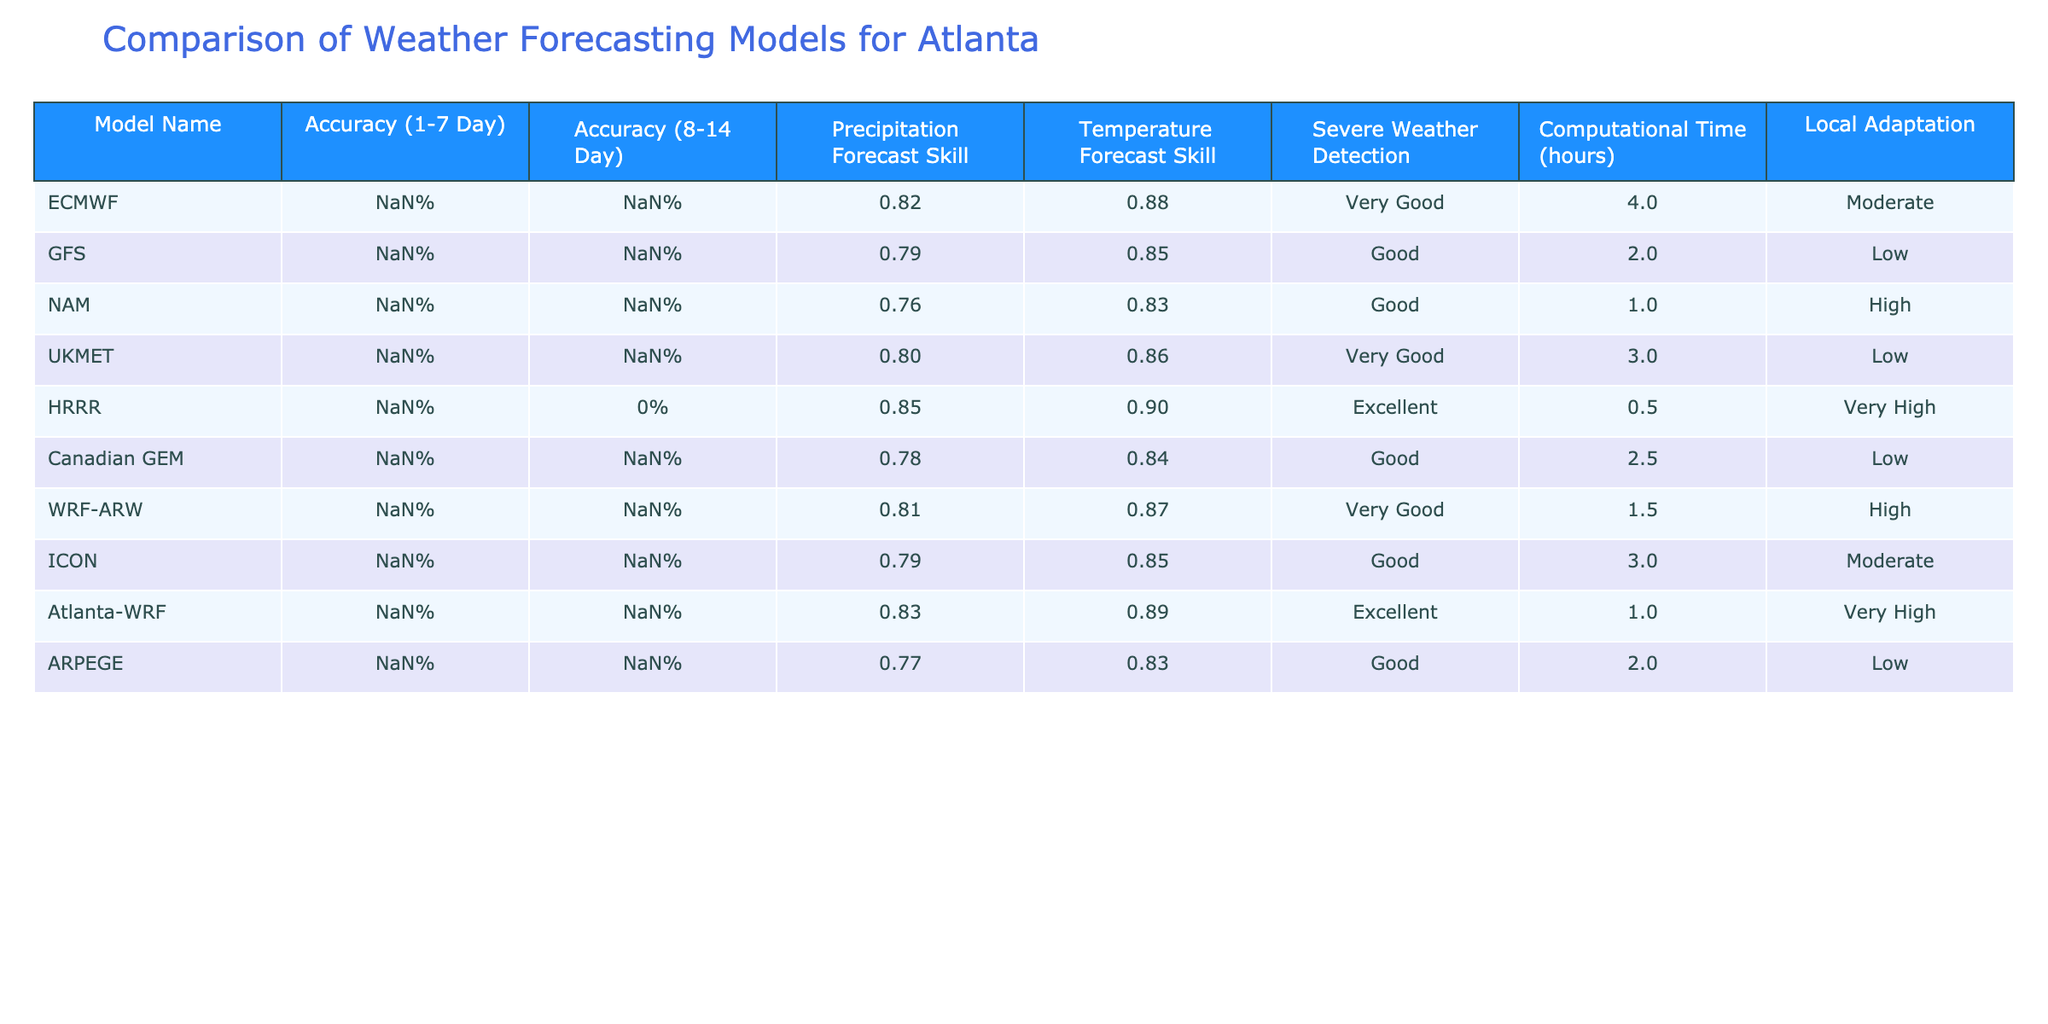What's the highest accuracy for predicting 1-7 day weather? The model with the highest accuracy for predicting 1-7 day weather is HRRR with an accuracy of 88%.
Answer: 88% Which model has the best severe weather detection capability? According to the table, the HRRR and Atlanta-WRF models are rated "Excellent" for severe weather detection, which is the highest rating available.
Answer: HRRR and Atlanta-WRF What's the average accuracy for predicting 8-14 day weather across all models? To find the average accuracy for predicting 8-14 day weather, we sum the accuracies: (72% + 68% + 65% + 70% + N/A + 67% + 69% + 69% + 71% + 66%) / 9 valid models. Ignoring N/A for HRRR, we get (72 + 68 + 65 + 70 + 67 + 69 + 69 + 71 + 66) = 619%. Dividing by 9 gives us approximately 68.78%.
Answer: 68.78% Does the GFS model have a higher temperature forecast skill compared to the NAM model? The GFS model has a temperature forecast skill of 0.85, while the NAM model has a skill of 0.83. Therefore, GFS does have a higher skill than NAM.
Answer: Yes Which models have low local adaptation, and what are their accuracies? The models with low local adaptation are the GFS, UKMET, and Canadian GEM. Their respective accuracies for the 1-7 day forecast are 82%, 83%, and 81%.
Answer: GFS (82%), UKMET (83%), Canadian GEM (81%) Which model takes the longest computational time? The model that takes the longest computational time is ECMWF, which requires 4 hours.
Answer: 4 hours What is the difference in precipitation forecast skill between the HRRR model and the UKMET model? The HRRR model has a precipitation forecast skill of 0.85, while the UKMET model has a skill of 0.80. To find the difference, we calculate 0.85 - 0.80 = 0.05.
Answer: 0.05 How many models have a temperature forecast skill of 0.87 or higher? The models with a temperature forecast skill of 0.87 or higher are HRRR (0.90), ECMWF (0.88), and Atlanta-WRF (0.89). That makes a total of three models.
Answer: 3 Is the precipitation forecast skill of the Atlanta-WRF model greater than that of the Canadian GEM model? The Atlanta-WRF model has a precipitation forecast skill of 0.83, while the Canadian GEM model has a skill of 0.78. Since 0.83 is greater than 0.78, the statement is true.
Answer: Yes 